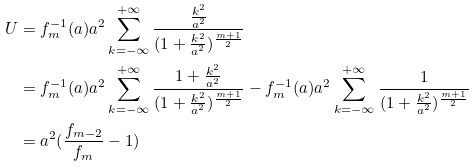Convert formula to latex. <formula><loc_0><loc_0><loc_500><loc_500>U & = f _ { m } ^ { - 1 } ( a ) a ^ { 2 } \sum _ { k = - \infty } ^ { + \infty } \frac { \frac { k ^ { 2 } } { a ^ { 2 } } } { ( 1 + \frac { k ^ { 2 } } { a ^ { 2 } } ) ^ { \frac { m + 1 } { 2 } } } \\ & = f _ { m } ^ { - 1 } ( a ) a ^ { 2 } \sum _ { k = - \infty } ^ { + \infty } \frac { 1 + \frac { k ^ { 2 } } { a ^ { 2 } } } { ( 1 + \frac { k ^ { 2 } } { a ^ { 2 } } ) ^ { \frac { m + 1 } { 2 } } } - f _ { m } ^ { - 1 } ( a ) a ^ { 2 } \sum _ { k = - \infty } ^ { + \infty } \frac { 1 } { ( 1 + \frac { k ^ { 2 } } { a ^ { 2 } } ) ^ { \frac { m + 1 } { 2 } } } \\ & = a ^ { 2 } ( \frac { f _ { m - 2 } } { f _ { m } } - 1 )</formula> 